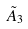<formula> <loc_0><loc_0><loc_500><loc_500>\tilde { A } _ { 3 }</formula> 